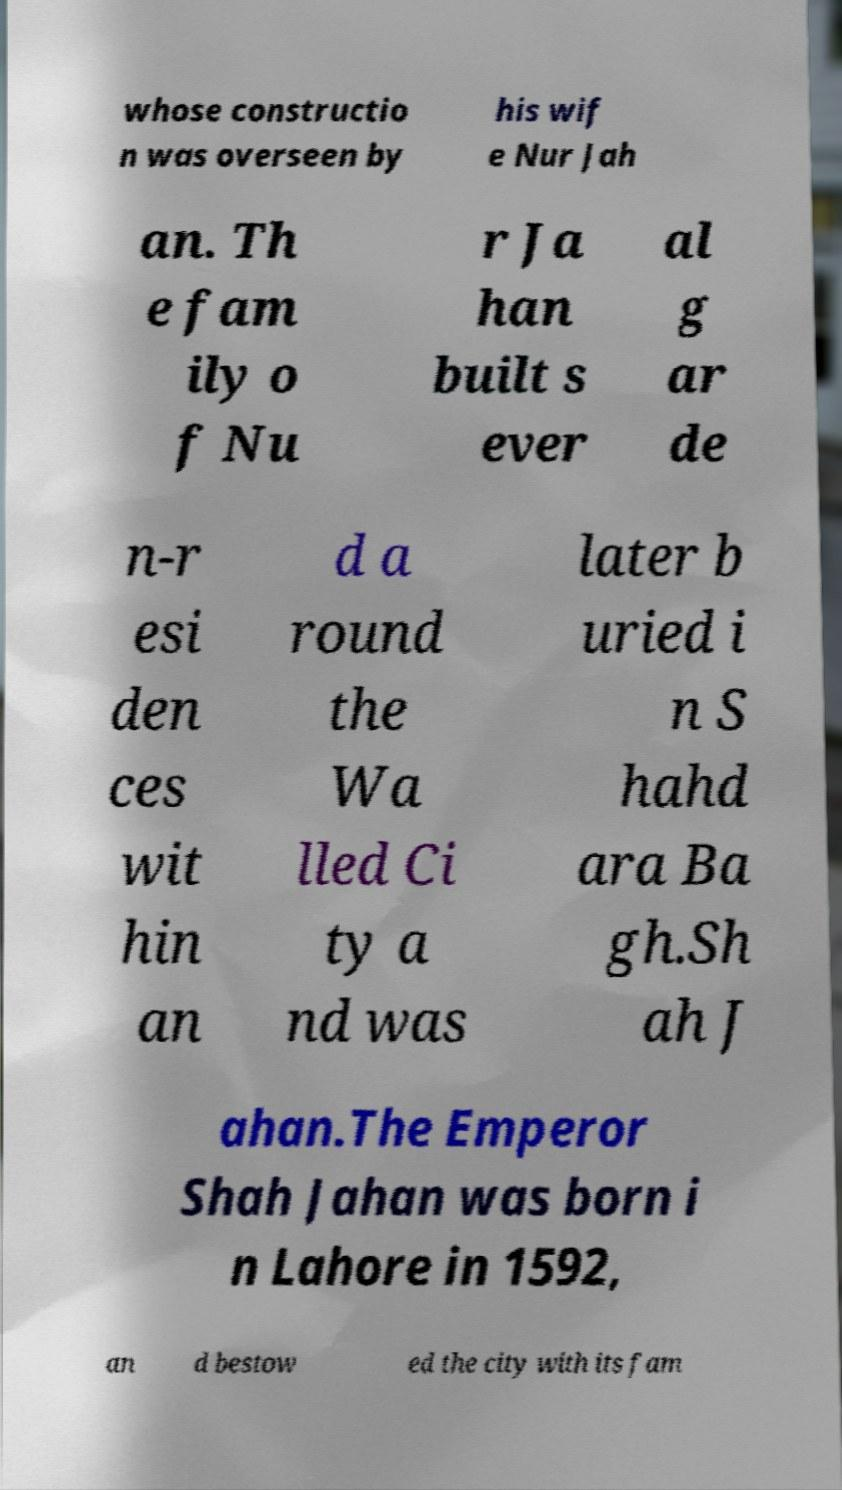There's text embedded in this image that I need extracted. Can you transcribe it verbatim? whose constructio n was overseen by his wif e Nur Jah an. Th e fam ily o f Nu r Ja han built s ever al g ar de n-r esi den ces wit hin an d a round the Wa lled Ci ty a nd was later b uried i n S hahd ara Ba gh.Sh ah J ahan.The Emperor Shah Jahan was born i n Lahore in 1592, an d bestow ed the city with its fam 